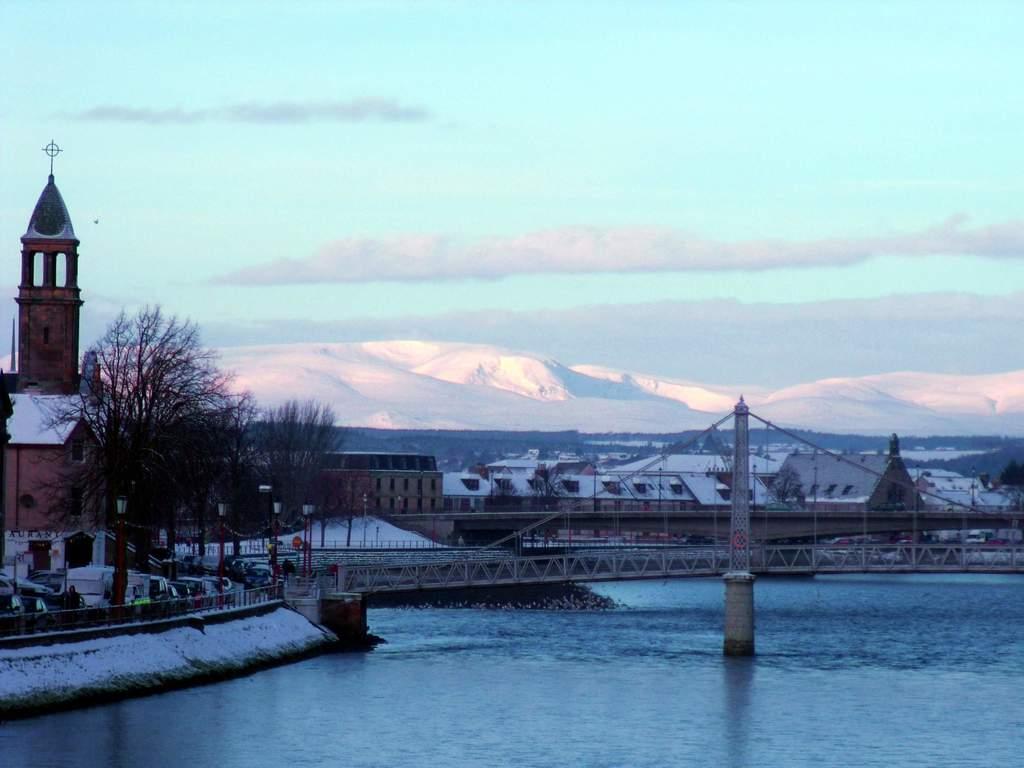Could you give a brief overview of what you see in this image? In this picture we can see a bridge and water. On the left side of the bridge there are poles with lights and behind the bridge there are trees, buildings, hills and the sky. 